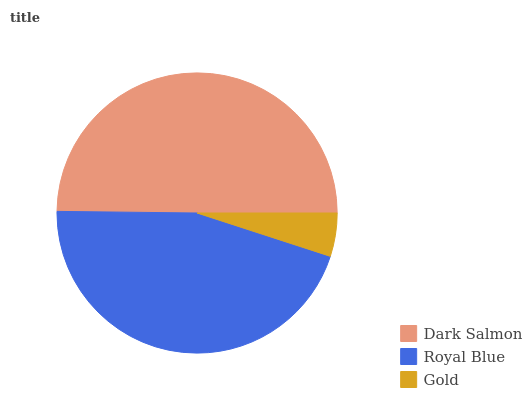Is Gold the minimum?
Answer yes or no. Yes. Is Dark Salmon the maximum?
Answer yes or no. Yes. Is Royal Blue the minimum?
Answer yes or no. No. Is Royal Blue the maximum?
Answer yes or no. No. Is Dark Salmon greater than Royal Blue?
Answer yes or no. Yes. Is Royal Blue less than Dark Salmon?
Answer yes or no. Yes. Is Royal Blue greater than Dark Salmon?
Answer yes or no. No. Is Dark Salmon less than Royal Blue?
Answer yes or no. No. Is Royal Blue the high median?
Answer yes or no. Yes. Is Royal Blue the low median?
Answer yes or no. Yes. Is Gold the high median?
Answer yes or no. No. Is Dark Salmon the low median?
Answer yes or no. No. 